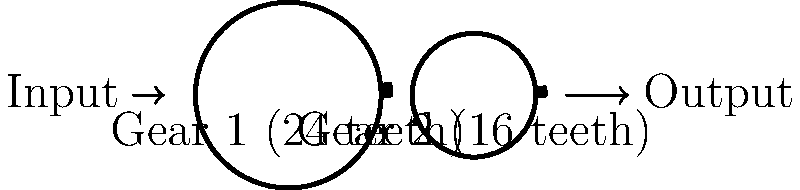In a simple gear train, Gear 1 has 24 teeth and Gear 2 has 16 teeth. If the input speed of Gear 1 is 120 RPM, what is the efficiency of the gear train, assuming a power loss of 5% due to friction? To determine the efficiency of the simple gear train, we need to follow these steps:

1. Calculate the gear ratio:
   Gear ratio = $\frac{\text{Number of teeth on driven gear}}{\text{Number of teeth on driving gear}} = \frac{16}{24} = \frac{2}{3}$

2. Calculate the output speed:
   Output speed = Input speed × Gear ratio
   $= 120 \text{ RPM} \times \frac{2}{3} = 80 \text{ RPM}$

3. Calculate the ideal power transmission (assuming no losses):
   Ideal power transmission = 100%

4. Account for the given power loss due to friction:
   Actual power transmission = 100% - 5% = 95%

5. Calculate the efficiency:
   Efficiency = $\frac{\text{Actual power transmission}}{\text{Ideal power transmission}} \times 100\%$
   $= \frac{95\%}{100\%} \times 100\% = 95\%$

The efficiency of the gear train is 95%.
Answer: 95% 